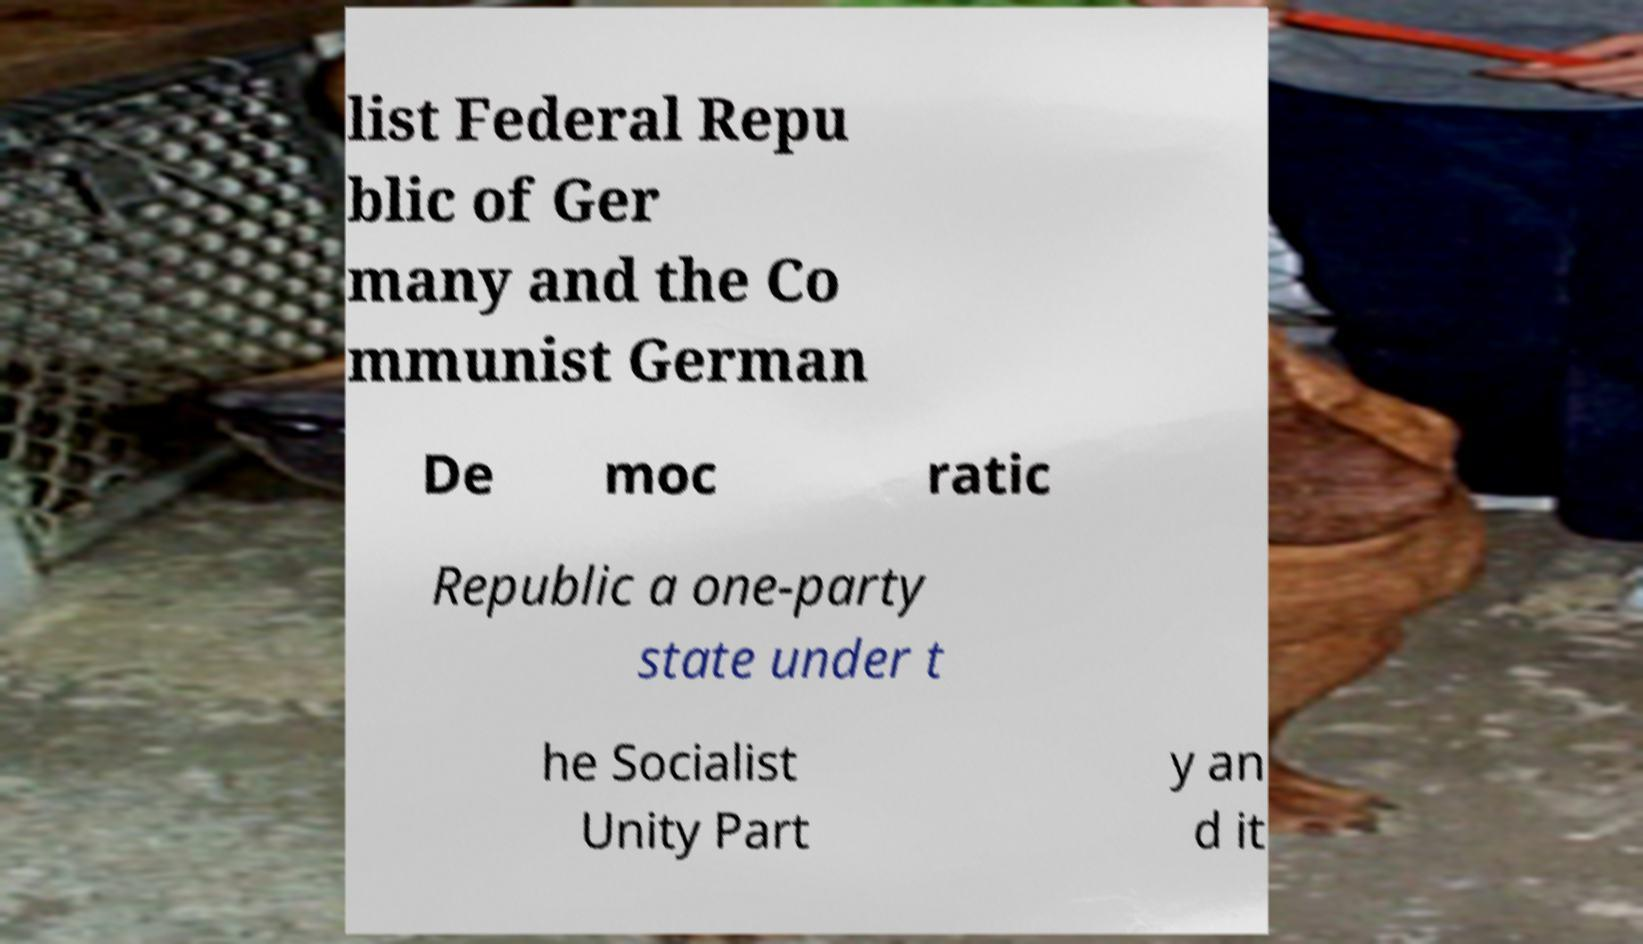Can you read and provide the text displayed in the image?This photo seems to have some interesting text. Can you extract and type it out for me? list Federal Repu blic of Ger many and the Co mmunist German De moc ratic Republic a one-party state under t he Socialist Unity Part y an d it 